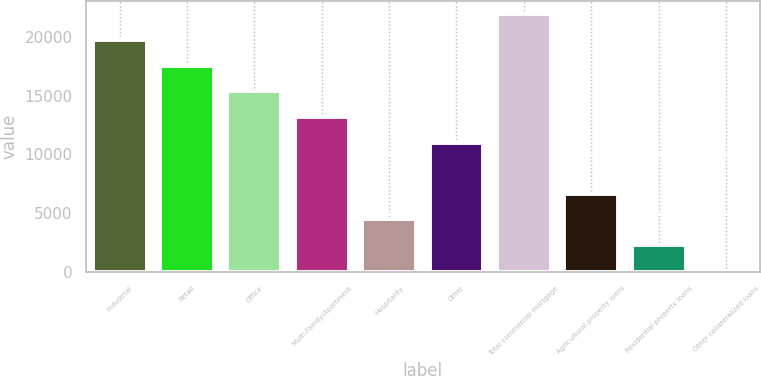<chart> <loc_0><loc_0><loc_500><loc_500><bar_chart><fcel>Industrial<fcel>Retail<fcel>Office<fcel>Multi-Family/Apartment<fcel>Hospitality<fcel>Other<fcel>Total commercial mortgage<fcel>Agricultural property loans<fcel>Residential property loans<fcel>Other collateralized loans<nl><fcel>19737.6<fcel>17553.2<fcel>15368.8<fcel>13184.4<fcel>4446.8<fcel>11000<fcel>21922<fcel>6631.2<fcel>2262.4<fcel>78<nl></chart> 